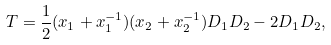<formula> <loc_0><loc_0><loc_500><loc_500>T = \frac { 1 } { 2 } ( x _ { 1 } + x ^ { - 1 } _ { 1 } ) ( x _ { 2 } + x ^ { - 1 } _ { 2 } ) D _ { 1 } D _ { 2 } - 2 D _ { 1 } D _ { 2 } ,</formula> 